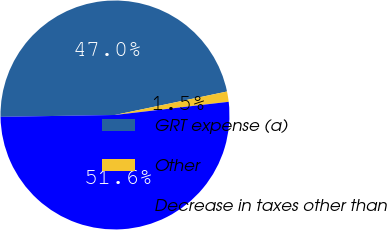Convert chart to OTSL. <chart><loc_0><loc_0><loc_500><loc_500><pie_chart><fcel>GRT expense (a)<fcel>Other<fcel>Decrease in taxes other than<nl><fcel>46.97%<fcel>1.45%<fcel>51.57%<nl></chart> 